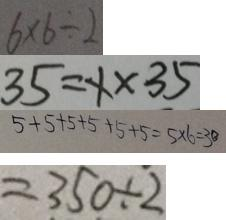<formula> <loc_0><loc_0><loc_500><loc_500>6 \times 6 \div 2 
 3 5 = x \times 3 5 
 5 + 5 + 5 + 5 + 5 + 5 = 5 \times 6 = 3 0 
 = 3 5 0 \div 2</formula> 